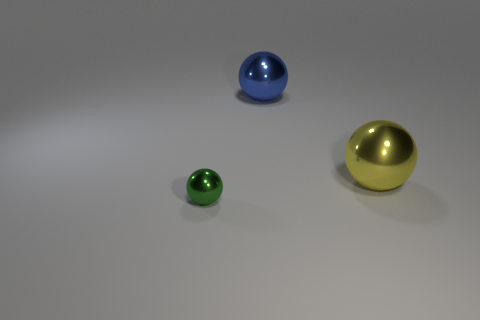Add 1 yellow shiny objects. How many objects exist? 4 Subtract 0 brown blocks. How many objects are left? 3 Subtract all big brown balls. Subtract all yellow objects. How many objects are left? 2 Add 1 large yellow things. How many large yellow things are left? 2 Add 1 metal spheres. How many metal spheres exist? 4 